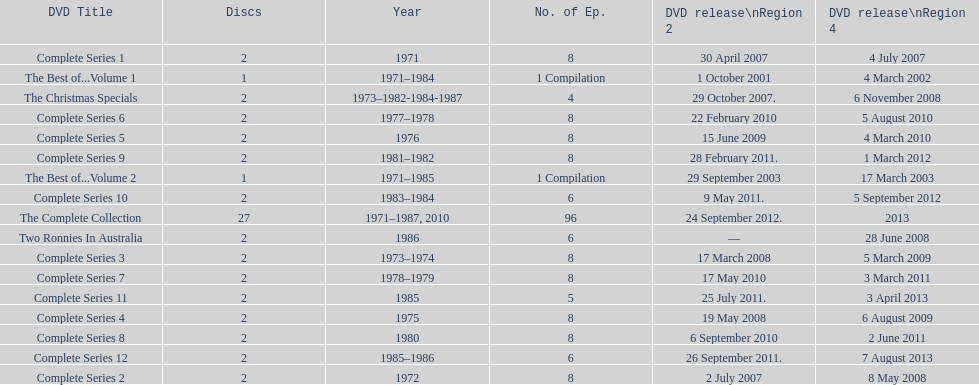What comes immediately after complete series 11? Complete Series 12. 